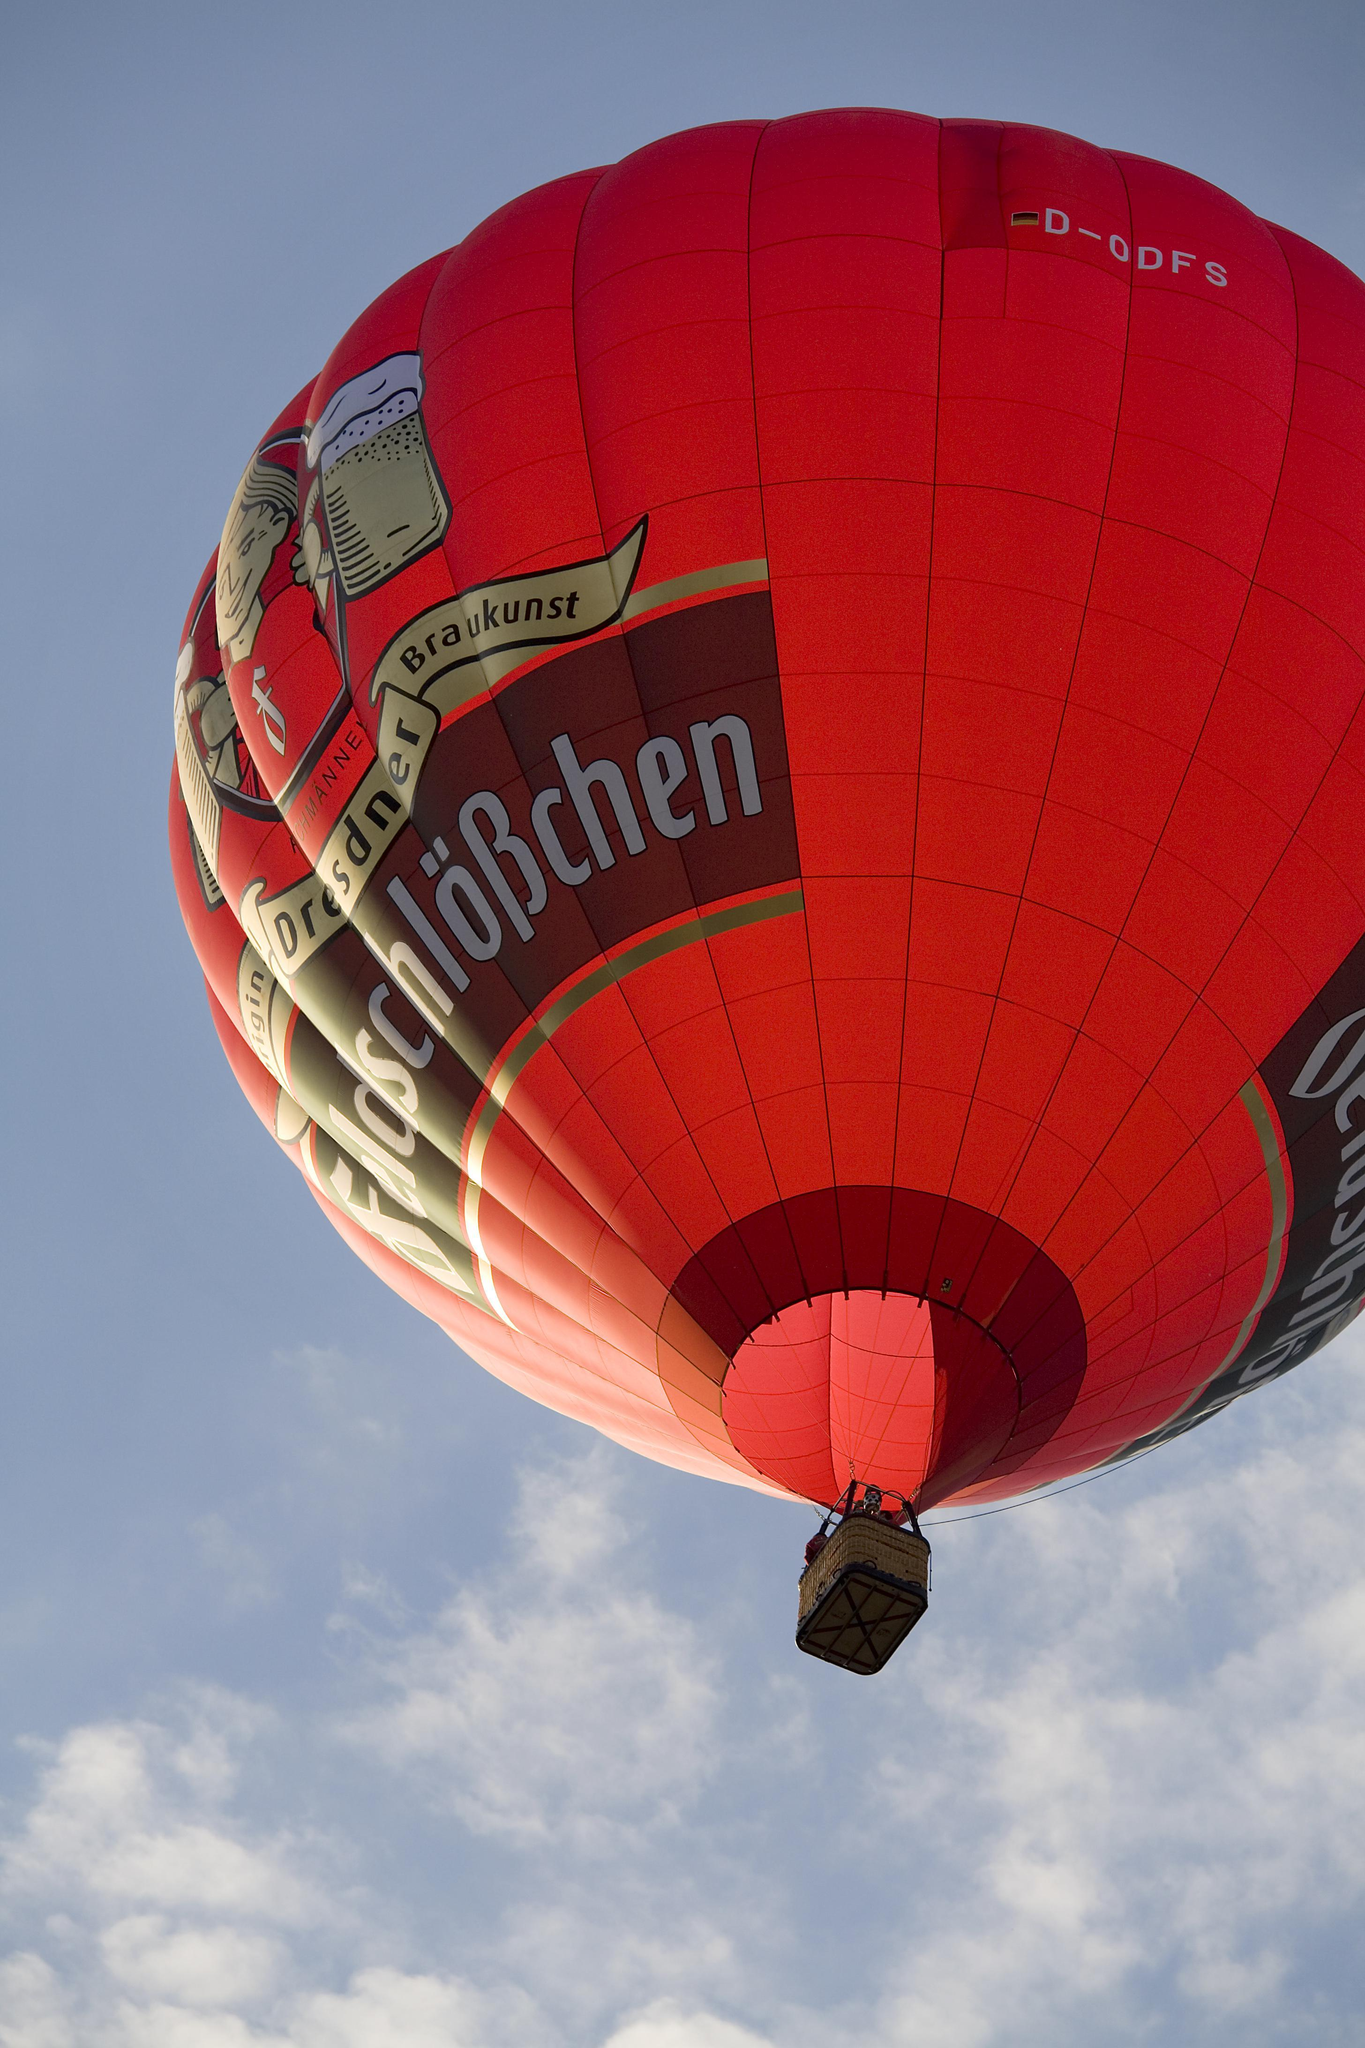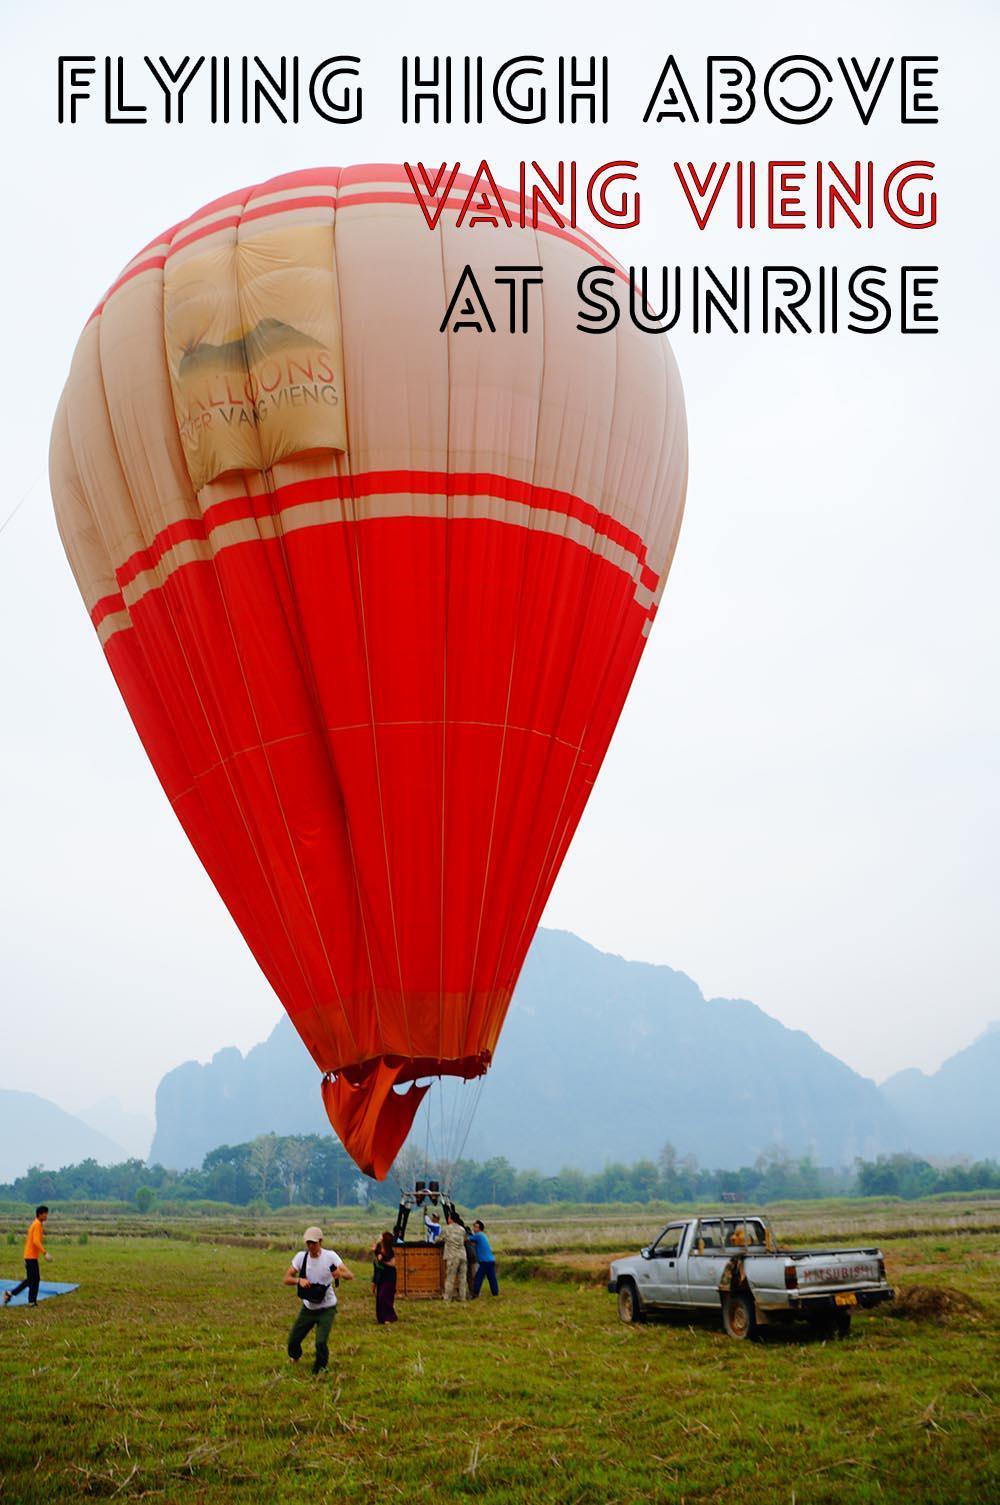The first image is the image on the left, the second image is the image on the right. For the images displayed, is the sentence "In total, two balloons are in the air rather than on the ground." factually correct? Answer yes or no. No. 